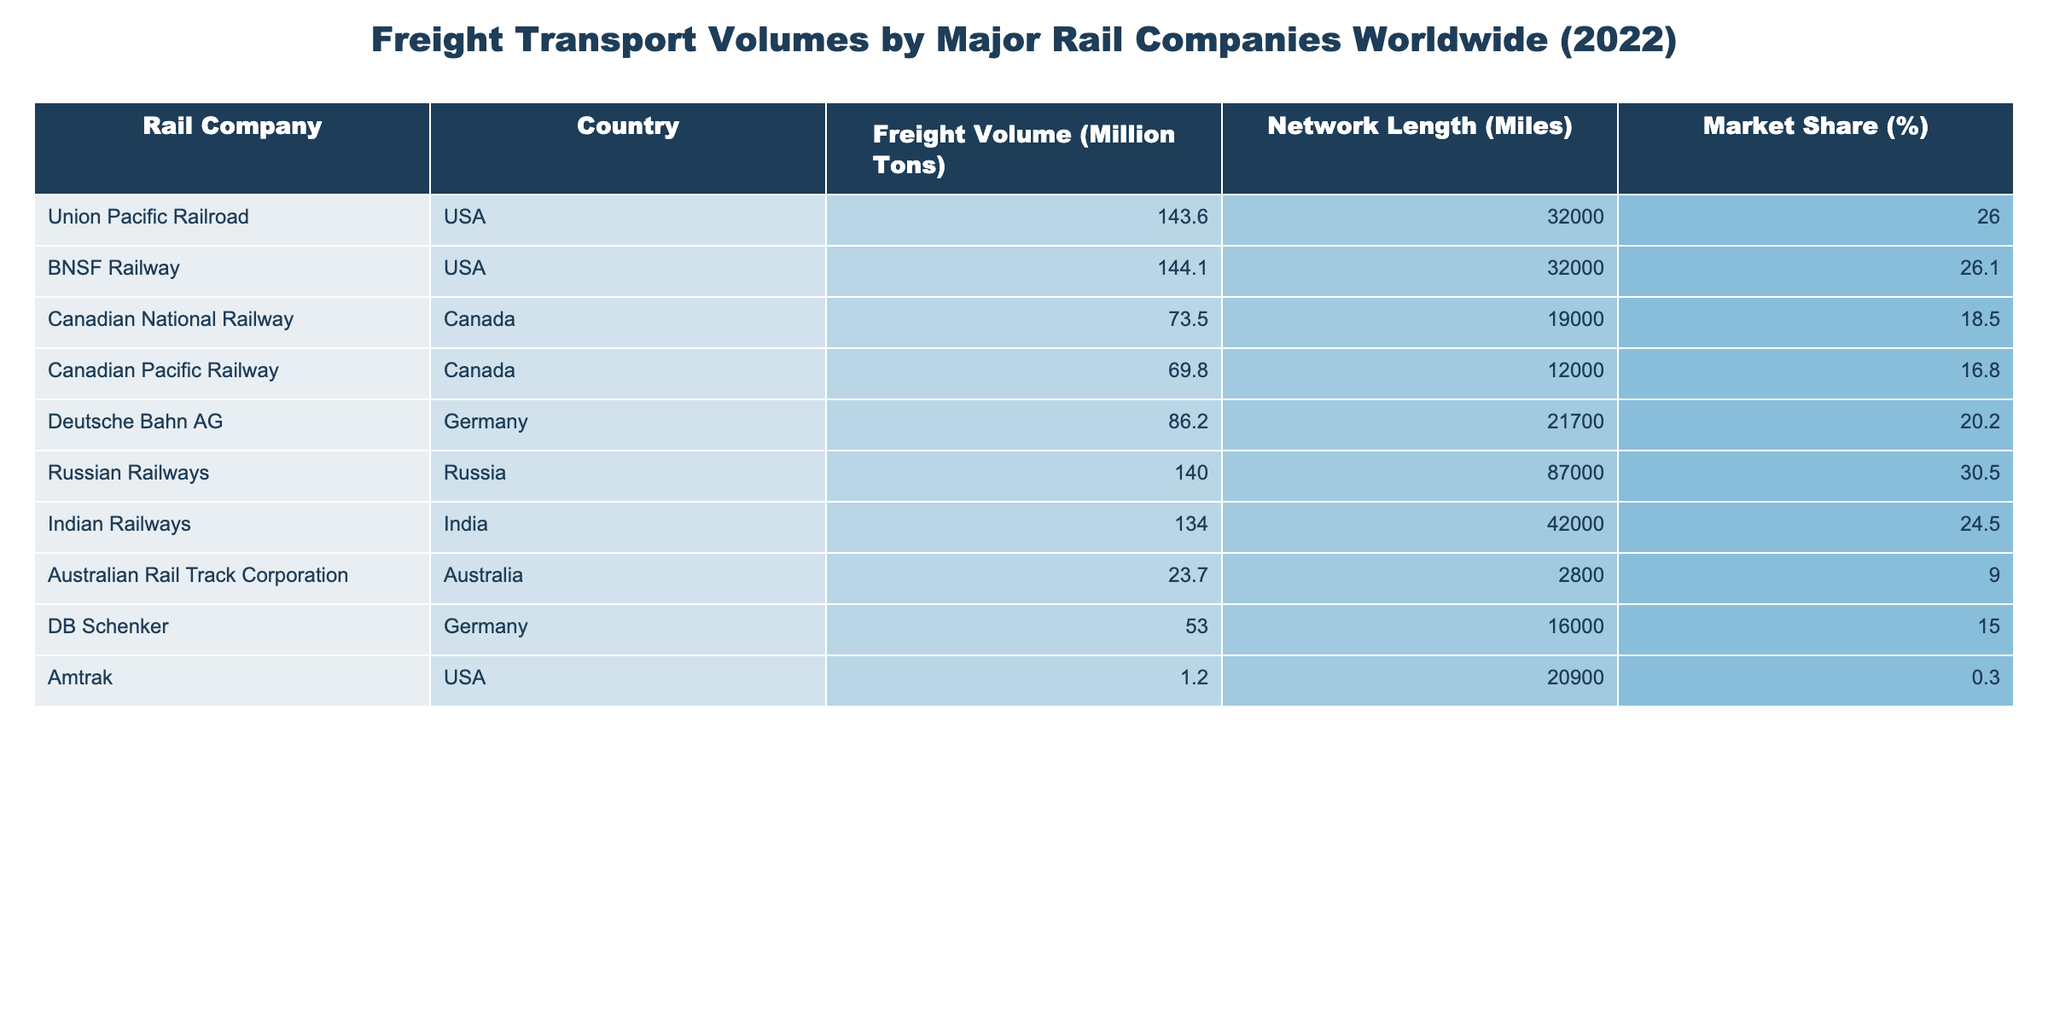What is the freight volume of BNSF Railway? The freight volume of BNSF Railway is listed in the table under the "Freight Volume (Million Tons)" column for that rail company. According to the table, BNSF Railway has a freight volume of 144.1 million tons.
Answer: 144.1 million tons Which company has the highest market share? To find the company with the highest market share, compare the values in the "Market Share (%)" column. The highest value is 30.5%, which corresponds to Russian Railways.
Answer: Russian Railways What is the total freight volume of all rail companies listed? To calculate the total freight volume, sum all the values in the "Freight Volume (Million Tons)" column: 143.6 + 144.1 + 73.5 + 69.8 + 86.2 + 140.0 + 134.0 + 23.7 + 53.0 + 1.2 =  795.1 million tons.
Answer: 795.1 million tons Does Indian Railways have a market share above 25%? Check the value in the "Market Share (%)" column for Indian Railways. It shows a market share of 24.5%, which is below 25%.
Answer: No What is the average freight volume of rail companies from Canada? The two Canadian companies are Canadian National Railway and Canadian Pacific Railway, with volumes of 73.5 and 69.8 million tons respectively. The sum of these volumes is 73.5 + 69.8 = 143.3 million tons. To find the average, divide by the number of companies (2): 143.3 / 2 = 71.65 million tons.
Answer: 71.65 million tons Which country has the longest rail network according to the table? Look at the "Network Length (Miles)" column and identify the company with the longest network. Russian Railways has a network length of 87,000 miles, which is the highest in the table.
Answer: Russia What is the difference in freight volume between Union Pacific Railroad and Canadian Pacific Railway? Union Pacific Railroad has a freight volume of 143.6 million tons, while Canadian Pacific Railway has 69.8 million tons. Calculate the difference: 143.6 - 69.8 = 73.8 million tons.
Answer: 73.8 million tons Is Amtrak's freight volume greater than 5 million tons? Check the freight volume of Amtrak, which is stated to be 1.2 million tons in the table. Since 1.2 million tons is less than 5 million tons, the answer is no.
Answer: No 